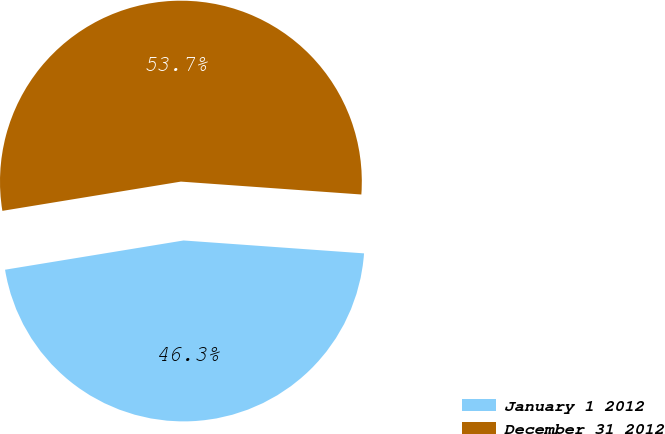Convert chart to OTSL. <chart><loc_0><loc_0><loc_500><loc_500><pie_chart><fcel>January 1 2012<fcel>December 31 2012<nl><fcel>46.28%<fcel>53.72%<nl></chart> 